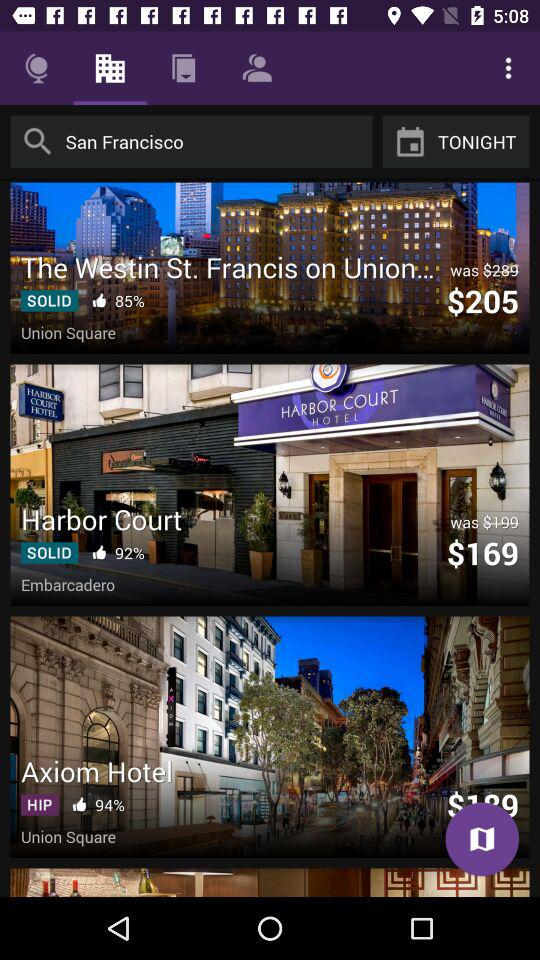How many hotels are displayed on the screen? There are three hotels prominently displayed on the screen, catering to different preferences and budgets. 'The Westin St. Francis', with an 85% recommendation rate and a special price of $205, promises a stately experience right on Union Square. 'Harbor Court Hotel', receiving an impressive 92% recommendation, offers a more budget-friendly stay for $169, located in the desirable Embarcadero area. Lastly, the 'Axiom Hotel', characterized as 'HIP' with a 94% recommendation score, is listed at $199 and adds a modern touch to the historic Union Square locale. 